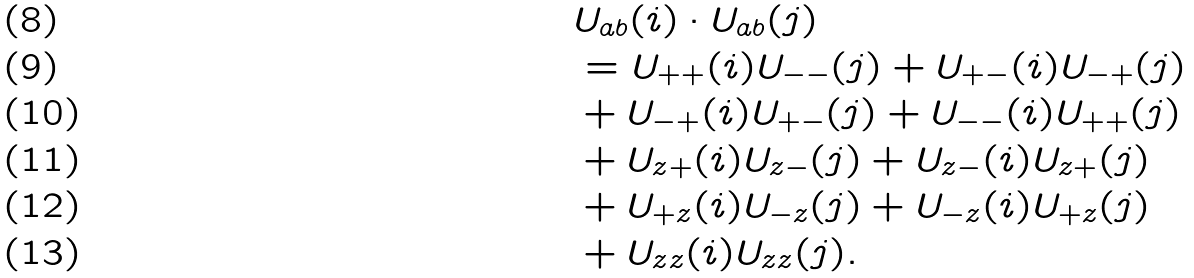Convert formula to latex. <formula><loc_0><loc_0><loc_500><loc_500>& { U } _ { a b } ( i ) \cdot { U } _ { a b } ( j ) \\ & = U _ { + + } ( i ) U _ { - - } ( j ) + U _ { + - } ( i ) U _ { - + } ( j ) \\ & + U _ { - + } ( i ) U _ { + - } ( j ) + U _ { - - } ( i ) U _ { + + } ( j ) \\ & + U _ { z + } ( i ) U _ { z - } ( j ) + U _ { z - } ( i ) U _ { z + } ( j ) \\ & + U _ { + z } ( i ) U _ { - z } ( j ) + U _ { - z } ( i ) U _ { + z } ( j ) \\ & + U _ { z z } ( i ) U _ { z z } ( j ) .</formula> 